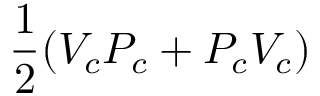Convert formula to latex. <formula><loc_0><loc_0><loc_500><loc_500>\frac { 1 } { 2 } ( V _ { c } P _ { c } + P _ { c } V _ { c } )</formula> 